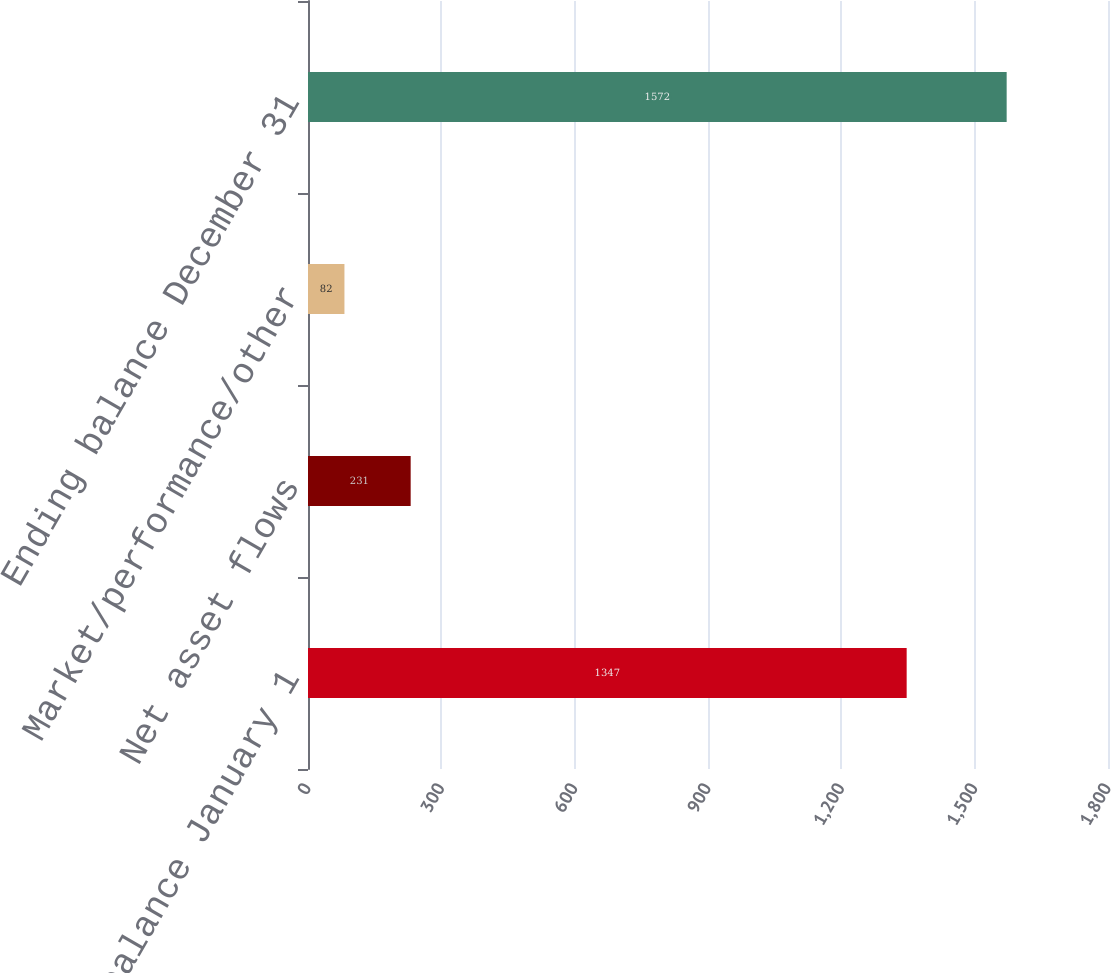Convert chart. <chart><loc_0><loc_0><loc_500><loc_500><bar_chart><fcel>Beginning balance January 1<fcel>Net asset flows<fcel>Market/performance/other<fcel>Ending balance December 31<nl><fcel>1347<fcel>231<fcel>82<fcel>1572<nl></chart> 